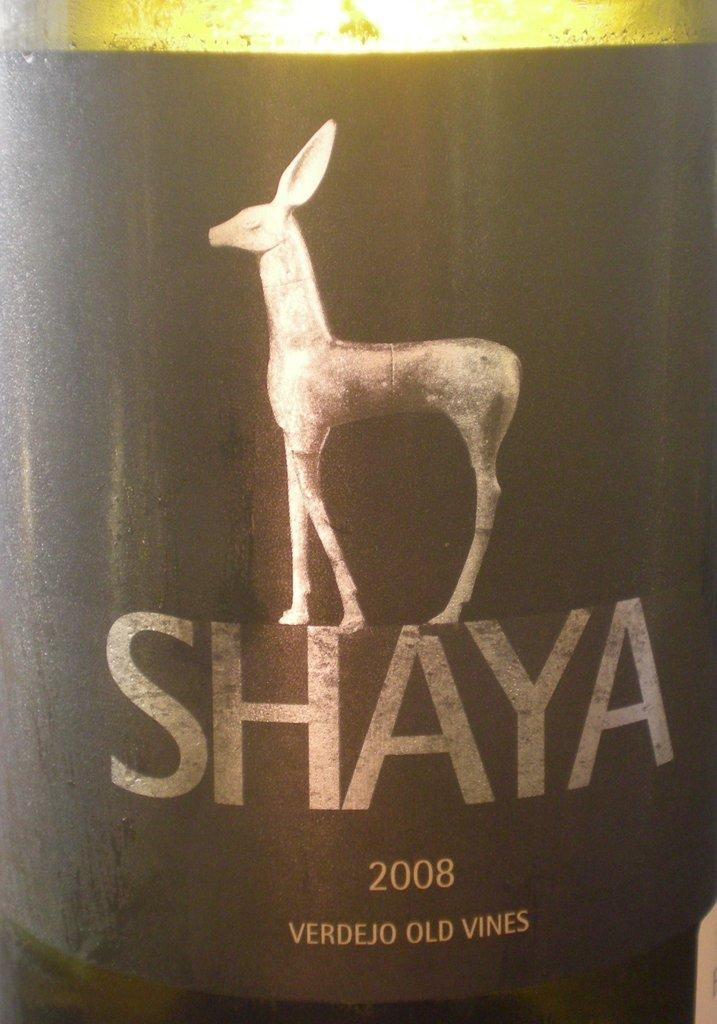What is present on the poster in the image? The poster contains text and an image. What is the poster attached to or placed on? The poster is on an object. How does the poster contribute to reducing pollution in the image? The poster does not have any direct impact on pollution in the image, as it is a static object containing text and an image. 